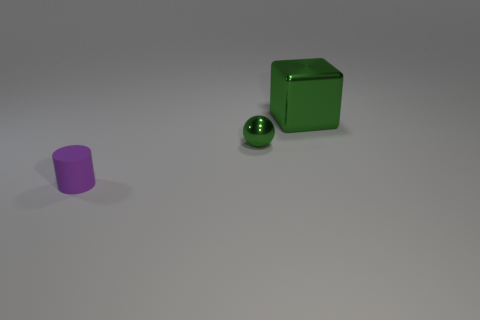Add 3 large cyan rubber cubes. How many objects exist? 6 Subtract all cylinders. How many objects are left? 2 Subtract 0 brown balls. How many objects are left? 3 Subtract all small red metallic cylinders. Subtract all large cubes. How many objects are left? 2 Add 2 green shiny objects. How many green shiny objects are left? 4 Add 3 blocks. How many blocks exist? 4 